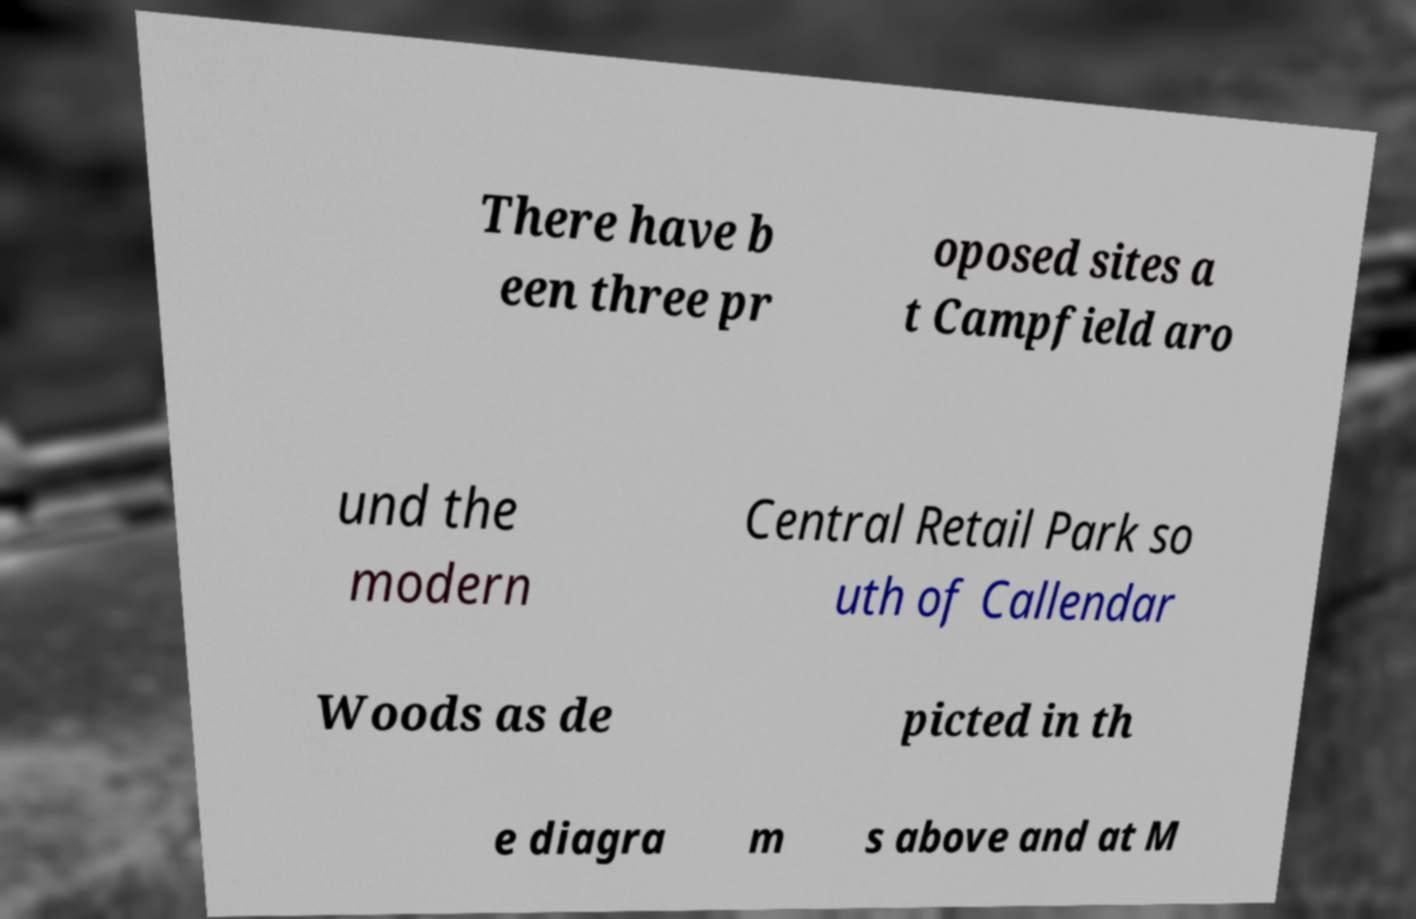Could you assist in decoding the text presented in this image and type it out clearly? There have b een three pr oposed sites a t Campfield aro und the modern Central Retail Park so uth of Callendar Woods as de picted in th e diagra m s above and at M 